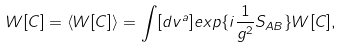Convert formula to latex. <formula><loc_0><loc_0><loc_500><loc_500>W [ C ] = \langle W [ C ] \rangle = \int [ d v ^ { a } ] e x p \{ i \frac { 1 } { g ^ { 2 } } S _ { A B } \} W [ C ] ,</formula> 